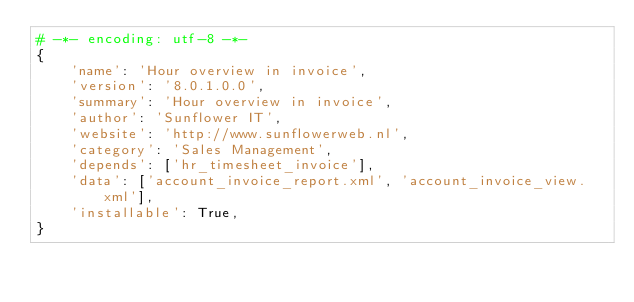Convert code to text. <code><loc_0><loc_0><loc_500><loc_500><_Python_># -*- encoding: utf-8 -*-
{
    'name': 'Hour overview in invoice',
    'version': '8.0.1.0.0',
    'summary': 'Hour overview in invoice',
    'author': 'Sunflower IT',  
    'website': 'http://www.sunflowerweb.nl',
    'category': 'Sales Management',
    'depends': ['hr_timesheet_invoice'],
    'data': ['account_invoice_report.xml', 'account_invoice_view.xml'],
    'installable': True,
}
</code> 